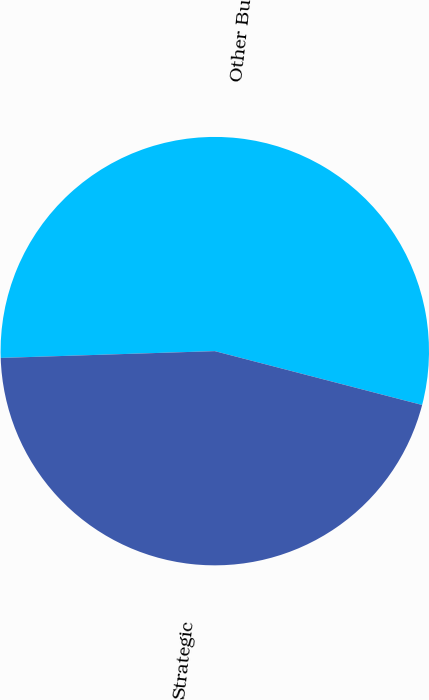Convert chart to OTSL. <chart><loc_0><loc_0><loc_500><loc_500><pie_chart><fcel>Other Builders<fcel>Strategic<nl><fcel>54.55%<fcel>45.45%<nl></chart> 